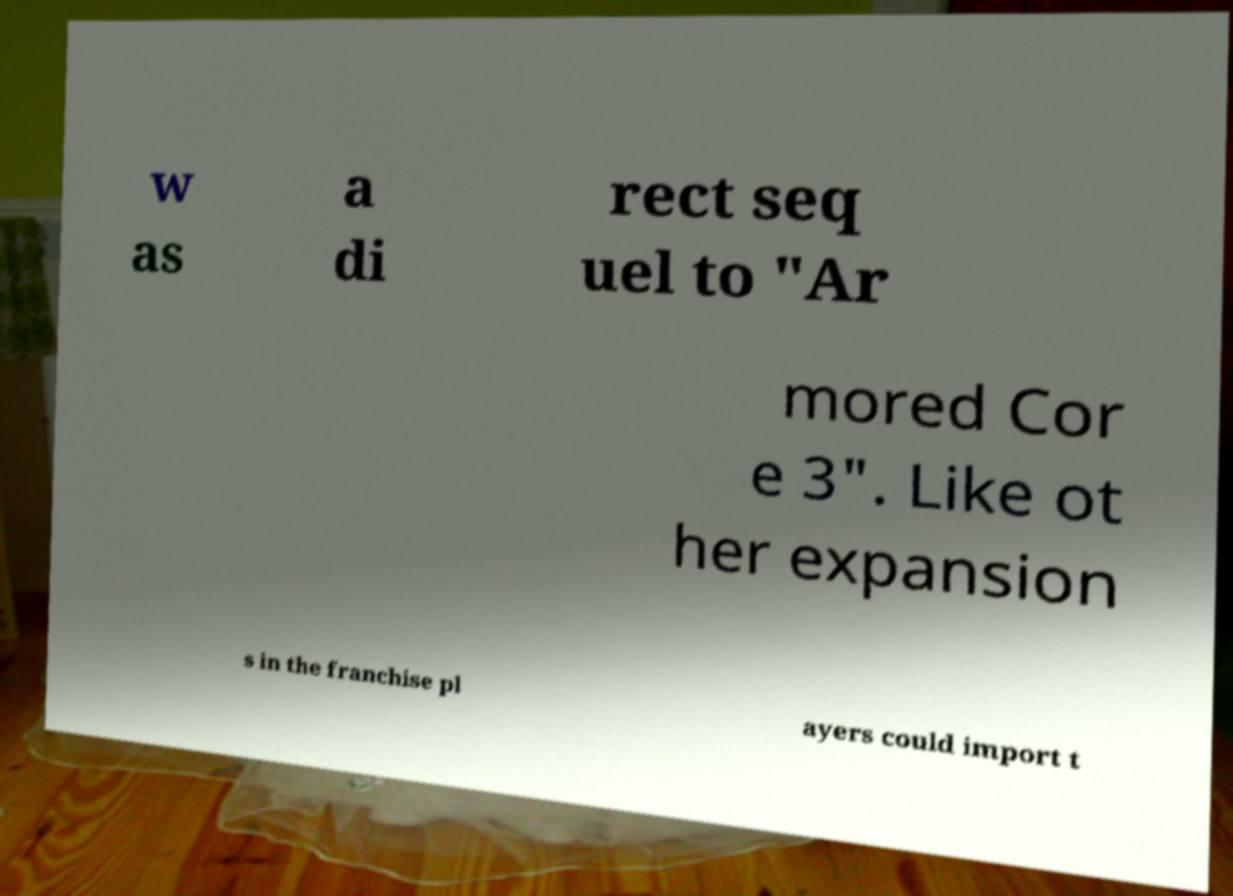For documentation purposes, I need the text within this image transcribed. Could you provide that? w as a di rect seq uel to "Ar mored Cor e 3". Like ot her expansion s in the franchise pl ayers could import t 